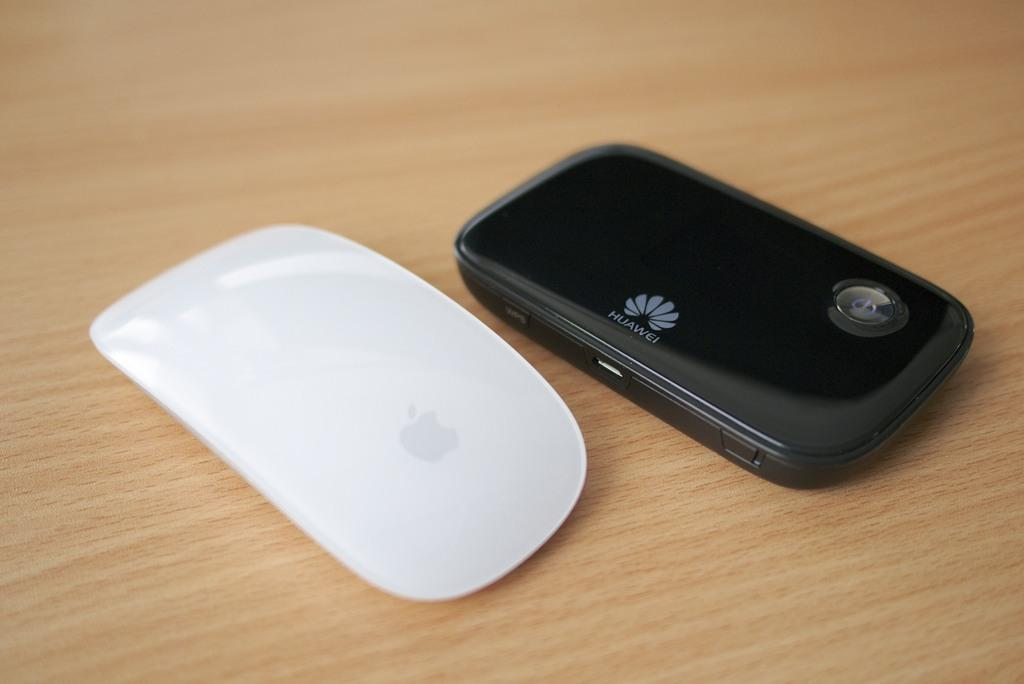<image>
Relay a brief, clear account of the picture shown. A Huawei phone sitting on a wood table. 